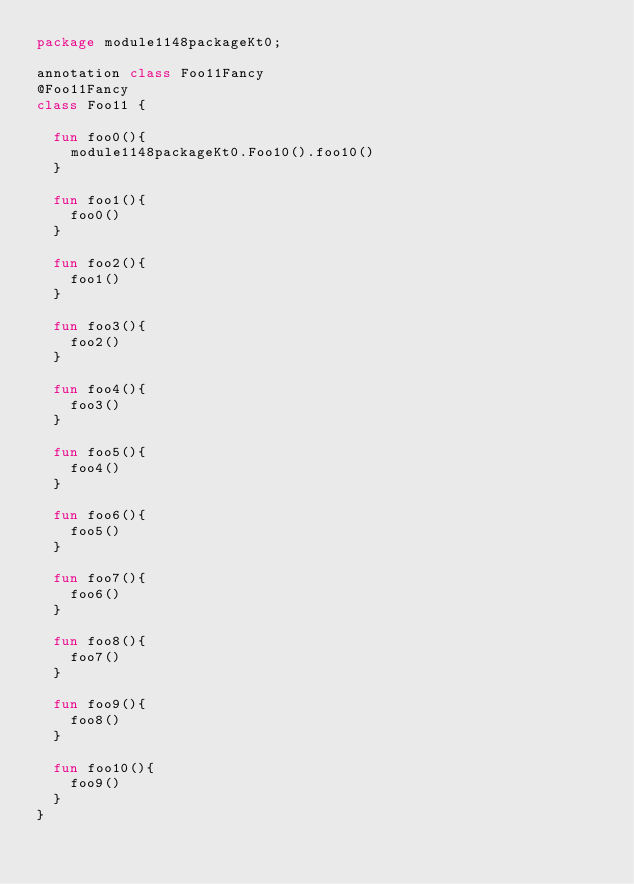Convert code to text. <code><loc_0><loc_0><loc_500><loc_500><_Kotlin_>package module1148packageKt0;

annotation class Foo11Fancy
@Foo11Fancy
class Foo11 {

  fun foo0(){
    module1148packageKt0.Foo10().foo10()
  }

  fun foo1(){
    foo0()
  }

  fun foo2(){
    foo1()
  }

  fun foo3(){
    foo2()
  }

  fun foo4(){
    foo3()
  }

  fun foo5(){
    foo4()
  }

  fun foo6(){
    foo5()
  }

  fun foo7(){
    foo6()
  }

  fun foo8(){
    foo7()
  }

  fun foo9(){
    foo8()
  }

  fun foo10(){
    foo9()
  }
}</code> 